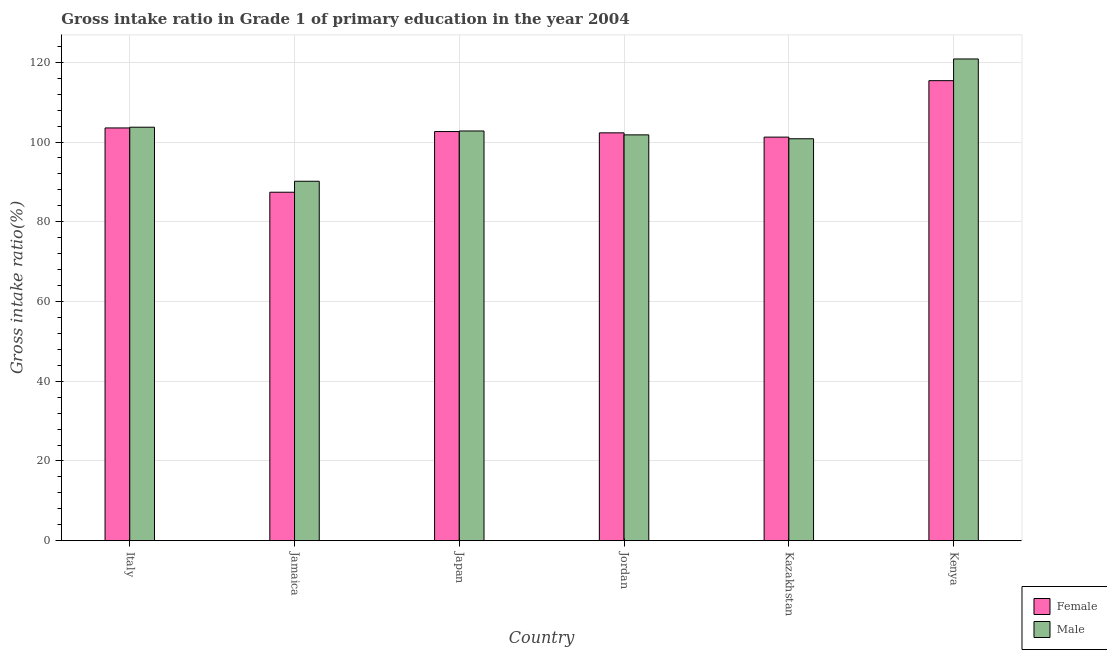How many bars are there on the 2nd tick from the left?
Your answer should be compact. 2. What is the label of the 4th group of bars from the left?
Ensure brevity in your answer.  Jordan. What is the gross intake ratio(male) in Jamaica?
Ensure brevity in your answer.  90.16. Across all countries, what is the maximum gross intake ratio(male)?
Keep it short and to the point. 120.83. Across all countries, what is the minimum gross intake ratio(male)?
Your response must be concise. 90.16. In which country was the gross intake ratio(female) maximum?
Offer a very short reply. Kenya. In which country was the gross intake ratio(male) minimum?
Offer a terse response. Jamaica. What is the total gross intake ratio(male) in the graph?
Make the answer very short. 620.08. What is the difference between the gross intake ratio(female) in Japan and that in Kazakhstan?
Make the answer very short. 1.39. What is the difference between the gross intake ratio(female) in Italy and the gross intake ratio(male) in Jordan?
Make the answer very short. 1.74. What is the average gross intake ratio(male) per country?
Provide a succinct answer. 103.35. What is the difference between the gross intake ratio(female) and gross intake ratio(male) in Japan?
Your answer should be very brief. -0.14. What is the ratio of the gross intake ratio(female) in Italy to that in Kazakhstan?
Offer a terse response. 1.02. Is the gross intake ratio(female) in Jamaica less than that in Jordan?
Ensure brevity in your answer.  Yes. What is the difference between the highest and the second highest gross intake ratio(female)?
Offer a terse response. 11.86. What is the difference between the highest and the lowest gross intake ratio(male)?
Keep it short and to the point. 30.67. In how many countries, is the gross intake ratio(female) greater than the average gross intake ratio(female) taken over all countries?
Ensure brevity in your answer.  4. Is the sum of the gross intake ratio(female) in Jamaica and Japan greater than the maximum gross intake ratio(male) across all countries?
Offer a very short reply. Yes. What does the 1st bar from the left in Jamaica represents?
Ensure brevity in your answer.  Female. How many bars are there?
Your answer should be compact. 12. Are all the bars in the graph horizontal?
Provide a succinct answer. No. How many countries are there in the graph?
Provide a short and direct response. 6. Does the graph contain grids?
Provide a succinct answer. Yes. Where does the legend appear in the graph?
Your response must be concise. Bottom right. How many legend labels are there?
Give a very brief answer. 2. How are the legend labels stacked?
Ensure brevity in your answer.  Vertical. What is the title of the graph?
Offer a very short reply. Gross intake ratio in Grade 1 of primary education in the year 2004. Does "Enforce a contract" appear as one of the legend labels in the graph?
Your answer should be very brief. No. What is the label or title of the Y-axis?
Provide a succinct answer. Gross intake ratio(%). What is the Gross intake ratio(%) in Female in Italy?
Ensure brevity in your answer.  103.53. What is the Gross intake ratio(%) in Male in Italy?
Provide a succinct answer. 103.72. What is the Gross intake ratio(%) of Female in Jamaica?
Make the answer very short. 87.41. What is the Gross intake ratio(%) of Male in Jamaica?
Ensure brevity in your answer.  90.16. What is the Gross intake ratio(%) in Female in Japan?
Give a very brief answer. 102.62. What is the Gross intake ratio(%) in Male in Japan?
Offer a terse response. 102.77. What is the Gross intake ratio(%) in Female in Jordan?
Your answer should be very brief. 102.3. What is the Gross intake ratio(%) in Male in Jordan?
Give a very brief answer. 101.79. What is the Gross intake ratio(%) in Female in Kazakhstan?
Keep it short and to the point. 101.23. What is the Gross intake ratio(%) in Male in Kazakhstan?
Give a very brief answer. 100.82. What is the Gross intake ratio(%) in Female in Kenya?
Ensure brevity in your answer.  115.39. What is the Gross intake ratio(%) in Male in Kenya?
Provide a succinct answer. 120.83. Across all countries, what is the maximum Gross intake ratio(%) of Female?
Provide a succinct answer. 115.39. Across all countries, what is the maximum Gross intake ratio(%) in Male?
Your response must be concise. 120.83. Across all countries, what is the minimum Gross intake ratio(%) in Female?
Keep it short and to the point. 87.41. Across all countries, what is the minimum Gross intake ratio(%) in Male?
Provide a short and direct response. 90.16. What is the total Gross intake ratio(%) of Female in the graph?
Your answer should be compact. 612.49. What is the total Gross intake ratio(%) in Male in the graph?
Make the answer very short. 620.08. What is the difference between the Gross intake ratio(%) of Female in Italy and that in Jamaica?
Provide a short and direct response. 16.12. What is the difference between the Gross intake ratio(%) of Male in Italy and that in Jamaica?
Provide a short and direct response. 13.56. What is the difference between the Gross intake ratio(%) of Female in Italy and that in Japan?
Give a very brief answer. 0.91. What is the difference between the Gross intake ratio(%) in Female in Italy and that in Jordan?
Your answer should be very brief. 1.23. What is the difference between the Gross intake ratio(%) of Male in Italy and that in Jordan?
Offer a very short reply. 1.92. What is the difference between the Gross intake ratio(%) of Female in Italy and that in Kazakhstan?
Provide a short and direct response. 2.3. What is the difference between the Gross intake ratio(%) in Male in Italy and that in Kazakhstan?
Offer a terse response. 2.9. What is the difference between the Gross intake ratio(%) in Female in Italy and that in Kenya?
Give a very brief answer. -11.86. What is the difference between the Gross intake ratio(%) in Male in Italy and that in Kenya?
Your answer should be compact. -17.12. What is the difference between the Gross intake ratio(%) in Female in Jamaica and that in Japan?
Give a very brief answer. -15.21. What is the difference between the Gross intake ratio(%) of Male in Jamaica and that in Japan?
Provide a short and direct response. -12.61. What is the difference between the Gross intake ratio(%) in Female in Jamaica and that in Jordan?
Make the answer very short. -14.89. What is the difference between the Gross intake ratio(%) of Male in Jamaica and that in Jordan?
Your answer should be compact. -11.63. What is the difference between the Gross intake ratio(%) of Female in Jamaica and that in Kazakhstan?
Make the answer very short. -13.82. What is the difference between the Gross intake ratio(%) in Male in Jamaica and that in Kazakhstan?
Offer a terse response. -10.66. What is the difference between the Gross intake ratio(%) of Female in Jamaica and that in Kenya?
Your response must be concise. -27.98. What is the difference between the Gross intake ratio(%) of Male in Jamaica and that in Kenya?
Give a very brief answer. -30.67. What is the difference between the Gross intake ratio(%) of Female in Japan and that in Jordan?
Keep it short and to the point. 0.32. What is the difference between the Gross intake ratio(%) of Male in Japan and that in Jordan?
Your answer should be very brief. 0.98. What is the difference between the Gross intake ratio(%) in Female in Japan and that in Kazakhstan?
Your response must be concise. 1.39. What is the difference between the Gross intake ratio(%) of Male in Japan and that in Kazakhstan?
Make the answer very short. 1.95. What is the difference between the Gross intake ratio(%) in Female in Japan and that in Kenya?
Provide a short and direct response. -12.77. What is the difference between the Gross intake ratio(%) of Male in Japan and that in Kenya?
Make the answer very short. -18.06. What is the difference between the Gross intake ratio(%) in Female in Jordan and that in Kazakhstan?
Offer a terse response. 1.07. What is the difference between the Gross intake ratio(%) in Male in Jordan and that in Kazakhstan?
Offer a terse response. 0.98. What is the difference between the Gross intake ratio(%) of Female in Jordan and that in Kenya?
Give a very brief answer. -13.09. What is the difference between the Gross intake ratio(%) of Male in Jordan and that in Kenya?
Give a very brief answer. -19.04. What is the difference between the Gross intake ratio(%) in Female in Kazakhstan and that in Kenya?
Your answer should be compact. -14.16. What is the difference between the Gross intake ratio(%) of Male in Kazakhstan and that in Kenya?
Your answer should be very brief. -20.02. What is the difference between the Gross intake ratio(%) of Female in Italy and the Gross intake ratio(%) of Male in Jamaica?
Your answer should be very brief. 13.37. What is the difference between the Gross intake ratio(%) in Female in Italy and the Gross intake ratio(%) in Male in Japan?
Your answer should be compact. 0.76. What is the difference between the Gross intake ratio(%) in Female in Italy and the Gross intake ratio(%) in Male in Jordan?
Provide a succinct answer. 1.74. What is the difference between the Gross intake ratio(%) of Female in Italy and the Gross intake ratio(%) of Male in Kazakhstan?
Offer a terse response. 2.71. What is the difference between the Gross intake ratio(%) in Female in Italy and the Gross intake ratio(%) in Male in Kenya?
Provide a short and direct response. -17.3. What is the difference between the Gross intake ratio(%) of Female in Jamaica and the Gross intake ratio(%) of Male in Japan?
Your answer should be compact. -15.36. What is the difference between the Gross intake ratio(%) of Female in Jamaica and the Gross intake ratio(%) of Male in Jordan?
Provide a succinct answer. -14.38. What is the difference between the Gross intake ratio(%) in Female in Jamaica and the Gross intake ratio(%) in Male in Kazakhstan?
Give a very brief answer. -13.41. What is the difference between the Gross intake ratio(%) in Female in Jamaica and the Gross intake ratio(%) in Male in Kenya?
Your answer should be very brief. -33.42. What is the difference between the Gross intake ratio(%) in Female in Japan and the Gross intake ratio(%) in Male in Jordan?
Offer a terse response. 0.83. What is the difference between the Gross intake ratio(%) of Female in Japan and the Gross intake ratio(%) of Male in Kazakhstan?
Ensure brevity in your answer.  1.81. What is the difference between the Gross intake ratio(%) of Female in Japan and the Gross intake ratio(%) of Male in Kenya?
Offer a very short reply. -18.21. What is the difference between the Gross intake ratio(%) in Female in Jordan and the Gross intake ratio(%) in Male in Kazakhstan?
Your answer should be very brief. 1.49. What is the difference between the Gross intake ratio(%) of Female in Jordan and the Gross intake ratio(%) of Male in Kenya?
Make the answer very short. -18.53. What is the difference between the Gross intake ratio(%) in Female in Kazakhstan and the Gross intake ratio(%) in Male in Kenya?
Give a very brief answer. -19.6. What is the average Gross intake ratio(%) in Female per country?
Your response must be concise. 102.08. What is the average Gross intake ratio(%) in Male per country?
Offer a terse response. 103.35. What is the difference between the Gross intake ratio(%) in Female and Gross intake ratio(%) in Male in Italy?
Make the answer very short. -0.19. What is the difference between the Gross intake ratio(%) of Female and Gross intake ratio(%) of Male in Jamaica?
Offer a terse response. -2.75. What is the difference between the Gross intake ratio(%) in Female and Gross intake ratio(%) in Male in Japan?
Provide a succinct answer. -0.14. What is the difference between the Gross intake ratio(%) of Female and Gross intake ratio(%) of Male in Jordan?
Ensure brevity in your answer.  0.51. What is the difference between the Gross intake ratio(%) of Female and Gross intake ratio(%) of Male in Kazakhstan?
Keep it short and to the point. 0.41. What is the difference between the Gross intake ratio(%) in Female and Gross intake ratio(%) in Male in Kenya?
Your response must be concise. -5.44. What is the ratio of the Gross intake ratio(%) in Female in Italy to that in Jamaica?
Make the answer very short. 1.18. What is the ratio of the Gross intake ratio(%) of Male in Italy to that in Jamaica?
Your answer should be compact. 1.15. What is the ratio of the Gross intake ratio(%) in Female in Italy to that in Japan?
Your answer should be very brief. 1.01. What is the ratio of the Gross intake ratio(%) in Male in Italy to that in Japan?
Give a very brief answer. 1.01. What is the ratio of the Gross intake ratio(%) in Female in Italy to that in Jordan?
Your answer should be very brief. 1.01. What is the ratio of the Gross intake ratio(%) in Male in Italy to that in Jordan?
Provide a short and direct response. 1.02. What is the ratio of the Gross intake ratio(%) of Female in Italy to that in Kazakhstan?
Provide a short and direct response. 1.02. What is the ratio of the Gross intake ratio(%) of Male in Italy to that in Kazakhstan?
Provide a succinct answer. 1.03. What is the ratio of the Gross intake ratio(%) in Female in Italy to that in Kenya?
Provide a succinct answer. 0.9. What is the ratio of the Gross intake ratio(%) in Male in Italy to that in Kenya?
Make the answer very short. 0.86. What is the ratio of the Gross intake ratio(%) of Female in Jamaica to that in Japan?
Keep it short and to the point. 0.85. What is the ratio of the Gross intake ratio(%) in Male in Jamaica to that in Japan?
Provide a succinct answer. 0.88. What is the ratio of the Gross intake ratio(%) in Female in Jamaica to that in Jordan?
Provide a short and direct response. 0.85. What is the ratio of the Gross intake ratio(%) of Male in Jamaica to that in Jordan?
Provide a succinct answer. 0.89. What is the ratio of the Gross intake ratio(%) in Female in Jamaica to that in Kazakhstan?
Provide a short and direct response. 0.86. What is the ratio of the Gross intake ratio(%) in Male in Jamaica to that in Kazakhstan?
Make the answer very short. 0.89. What is the ratio of the Gross intake ratio(%) of Female in Jamaica to that in Kenya?
Ensure brevity in your answer.  0.76. What is the ratio of the Gross intake ratio(%) of Male in Jamaica to that in Kenya?
Offer a terse response. 0.75. What is the ratio of the Gross intake ratio(%) in Male in Japan to that in Jordan?
Ensure brevity in your answer.  1.01. What is the ratio of the Gross intake ratio(%) in Female in Japan to that in Kazakhstan?
Give a very brief answer. 1.01. What is the ratio of the Gross intake ratio(%) of Male in Japan to that in Kazakhstan?
Offer a very short reply. 1.02. What is the ratio of the Gross intake ratio(%) in Female in Japan to that in Kenya?
Your response must be concise. 0.89. What is the ratio of the Gross intake ratio(%) of Male in Japan to that in Kenya?
Your response must be concise. 0.85. What is the ratio of the Gross intake ratio(%) of Female in Jordan to that in Kazakhstan?
Provide a short and direct response. 1.01. What is the ratio of the Gross intake ratio(%) in Male in Jordan to that in Kazakhstan?
Provide a succinct answer. 1.01. What is the ratio of the Gross intake ratio(%) of Female in Jordan to that in Kenya?
Your response must be concise. 0.89. What is the ratio of the Gross intake ratio(%) of Male in Jordan to that in Kenya?
Your response must be concise. 0.84. What is the ratio of the Gross intake ratio(%) in Female in Kazakhstan to that in Kenya?
Provide a short and direct response. 0.88. What is the ratio of the Gross intake ratio(%) of Male in Kazakhstan to that in Kenya?
Keep it short and to the point. 0.83. What is the difference between the highest and the second highest Gross intake ratio(%) of Female?
Your response must be concise. 11.86. What is the difference between the highest and the second highest Gross intake ratio(%) of Male?
Give a very brief answer. 17.12. What is the difference between the highest and the lowest Gross intake ratio(%) in Female?
Provide a succinct answer. 27.98. What is the difference between the highest and the lowest Gross intake ratio(%) in Male?
Provide a succinct answer. 30.67. 